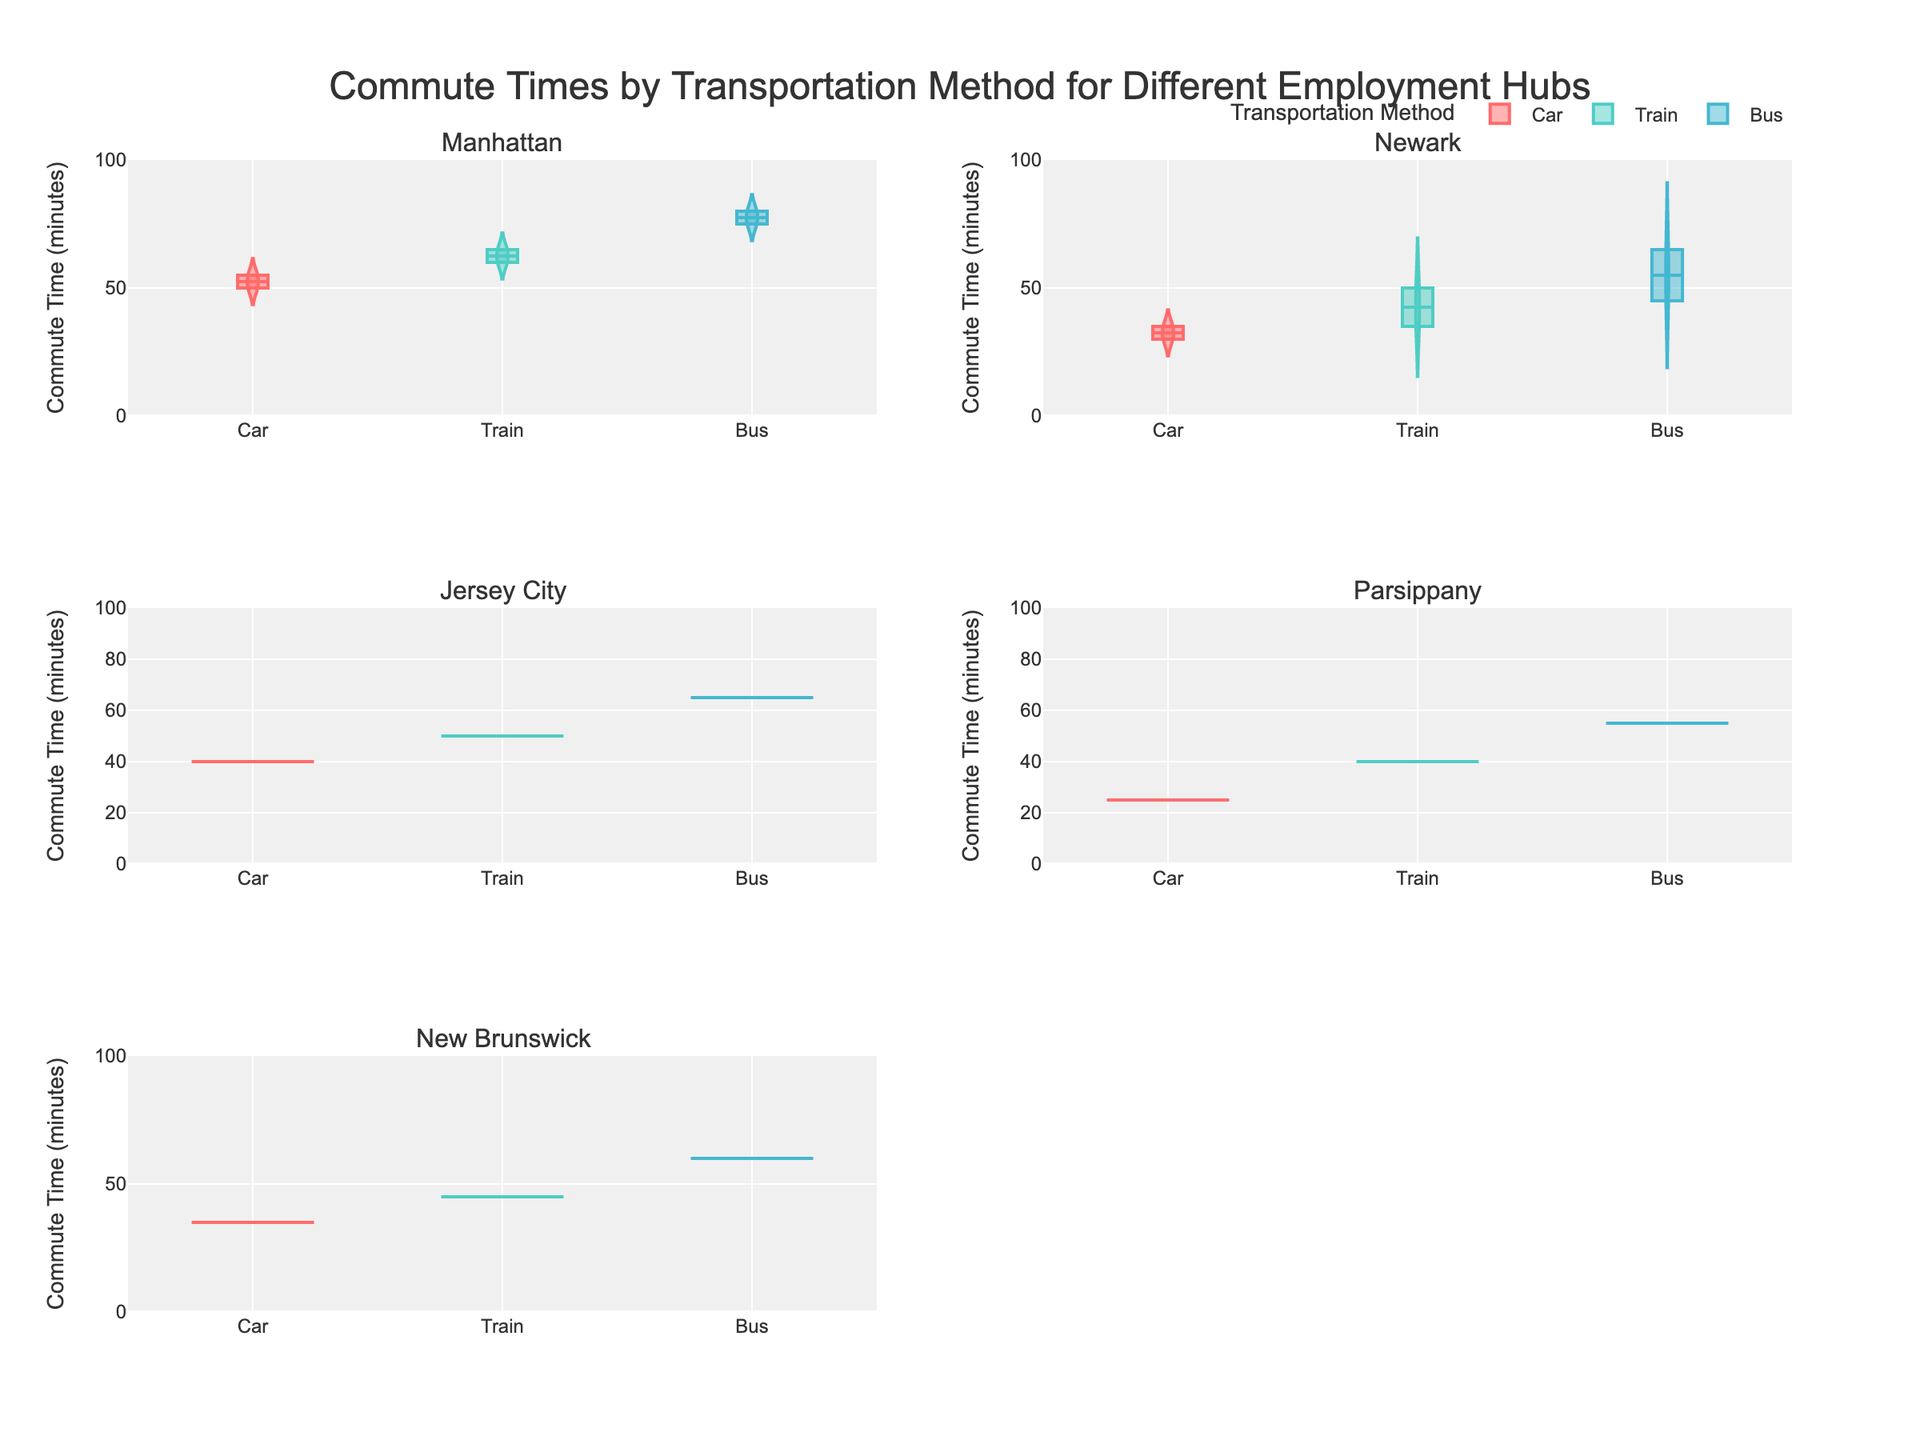What is the title of the figure? The title of the figure is located at the top and summarizes the content of the figure. It reads, "Commute Times by Transportation Method for Different Employment Hubs".
Answer: Commute Times by Transportation Method for Different Employment Hubs What are the transportation methods shown on the figure? The transportation methods are shown on each subplot by the different violin plots. They are Car, Train, and Bus.
Answer: Car, Train, Bus What is the range of commute times on the y-axis? The y-axis shows the range of commute times in minutes, which goes from 0 to 100.
Answer: 0 to 100 Which transportation method has the longest commute time to Manhattan? By observing the subplot for Manhattan, it's seen that Bus has the longest commute time compared to Car and Train.
Answer: Bus Which employment hub has the shortest commute time by Car? By comparing all the subplots, the employment hub with the shortest commute time by Car is Parsippany, which has a commute time of 25 minutes from Morristown.
Answer: Parsippany How does the commute time by Train compare between Westfield and Short Hills to Manhattan? In the subplots for Manhattan, the commute time by Train is around 65 minutes for Westfield and about 60 minutes for Short Hills.
Answer: Westfield: 65 minutes, Short Hills: 60 minutes What is the median commute time by Train to Newark? In the subplots for Newark, the commute time by Train shows central values around 35 minutes for Montclair and 50 minutes for Livingston. Since the specific median is not labeled, these central points can be taken as approximate medians.
Answer: Montclair: 35 minutes, Livingston: 50 minutes Which transportation method, on average, takes the longest for commuting to Jersey City? In the subplot for Jersey City, Bus shows the longest commute times compared to Car and Train, with values around 65 minutes.
Answer: Bus Compare the variability in commute times by Bus for all employment hubs. The variability in the violin plots can be seen by the width and spread of the plots. Bus commute times generally show wider and more variable plots across all employment hubs compared to Car and Train.
Answer: Bus has the highest variability 